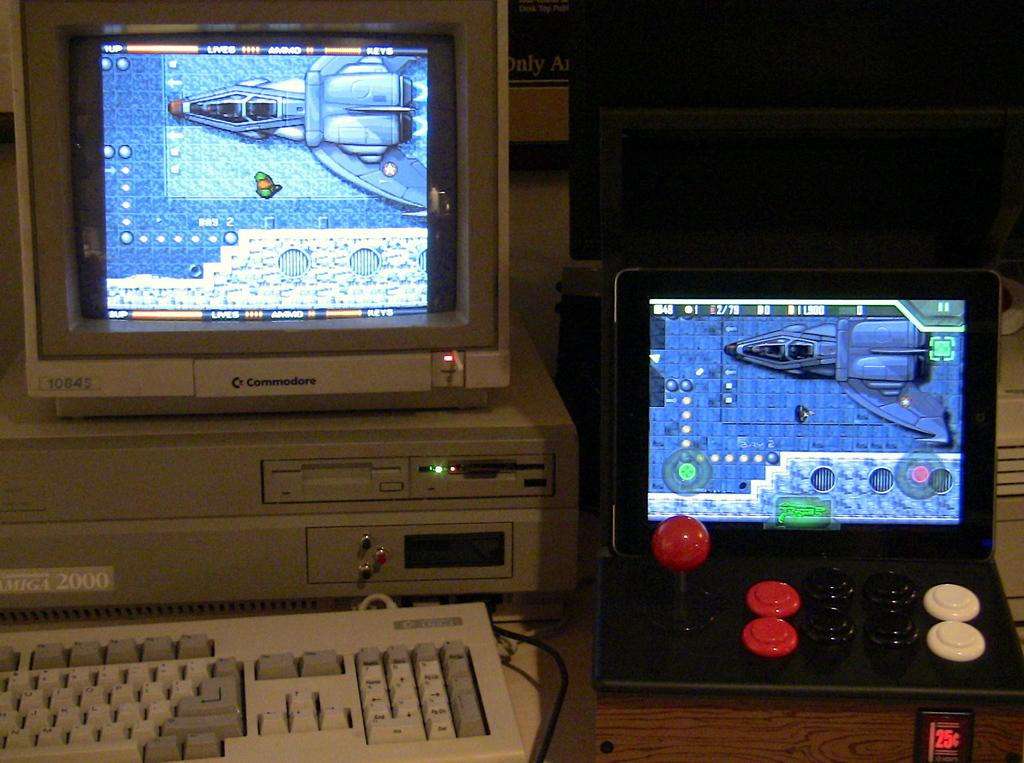<image>
Render a clear and concise summary of the photo. A Commodore computer monitor has the number 10845 on it. 